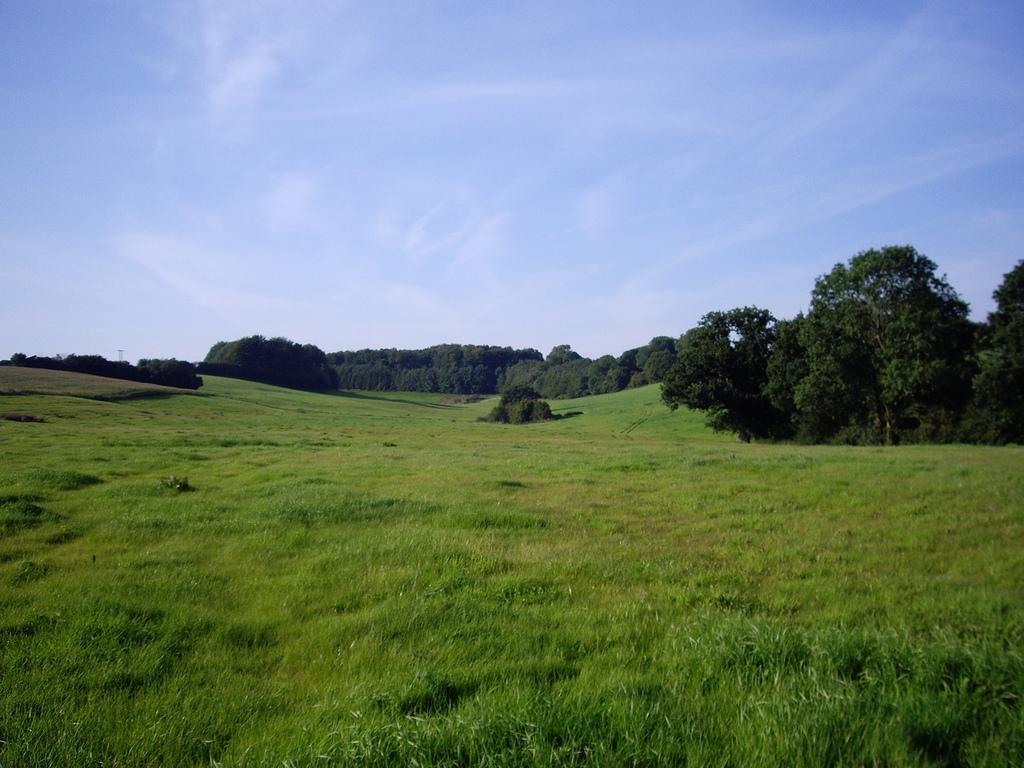Can you describe this image briefly? In this image we can see a group of trees a grass field. in the background, we can see the cloudy sky. 